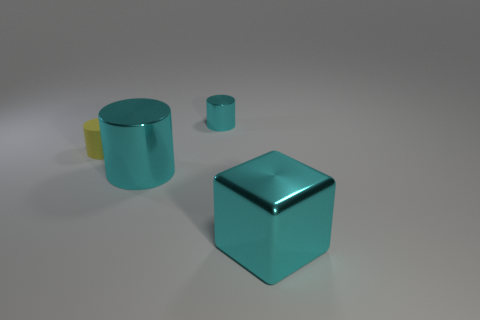What is the material of the big thing that is the same color as the large cube?
Give a very brief answer. Metal. The cylinder that is the same color as the tiny metallic thing is what size?
Provide a succinct answer. Large. How many objects are large red cylinders or cyan metallic cylinders left of the tiny cyan metallic thing?
Your answer should be very brief. 1. How many other things are there of the same shape as the tiny cyan object?
Give a very brief answer. 2. Are there fewer cylinders on the right side of the large shiny cube than matte cylinders that are to the left of the matte thing?
Make the answer very short. No. Are there any other things that are made of the same material as the large cube?
Give a very brief answer. Yes. What is the shape of the big object that is the same material as the big cyan cylinder?
Your answer should be compact. Cube. Is there any other thing of the same color as the shiny cube?
Ensure brevity in your answer.  Yes. What is the color of the small thing that is in front of the cyan metallic cylinder that is behind the yellow object?
Ensure brevity in your answer.  Yellow. The cylinder that is in front of the yellow cylinder that is in front of the cylinder behind the yellow rubber thing is made of what material?
Provide a short and direct response. Metal. 